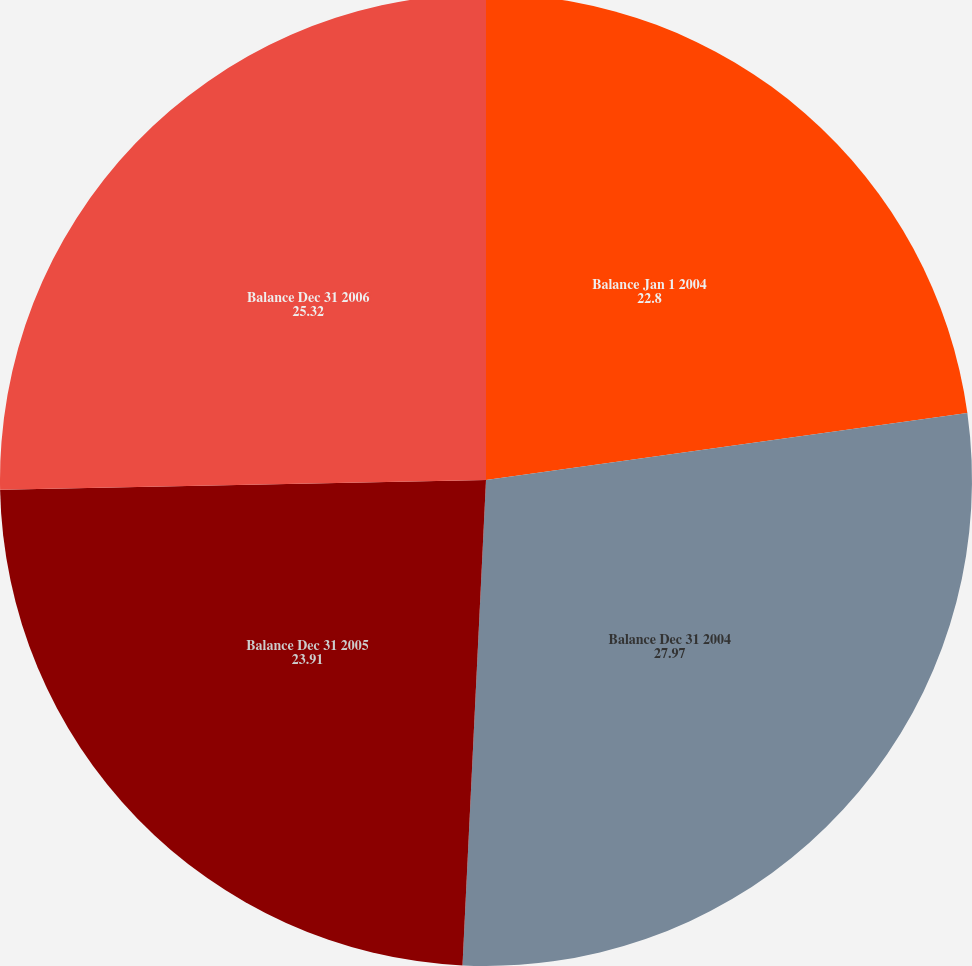Convert chart to OTSL. <chart><loc_0><loc_0><loc_500><loc_500><pie_chart><fcel>Balance Jan 1 2004<fcel>Balance Dec 31 2004<fcel>Balance Dec 31 2005<fcel>Balance Dec 31 2006<nl><fcel>22.8%<fcel>27.97%<fcel>23.91%<fcel>25.32%<nl></chart> 